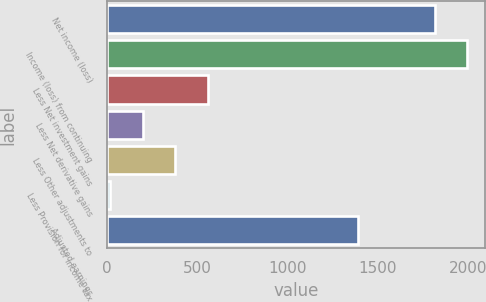<chart> <loc_0><loc_0><loc_500><loc_500><bar_chart><fcel>Net income (loss)<fcel>Income (loss) from continuing<fcel>Less Net investment gains<fcel>Less Net derivative gains<fcel>Less Other adjustments to<fcel>Less Provision for income tax<fcel>Adjusted earnings<nl><fcel>1813<fcel>1992.4<fcel>557.2<fcel>198.4<fcel>377.8<fcel>19<fcel>1388<nl></chart> 